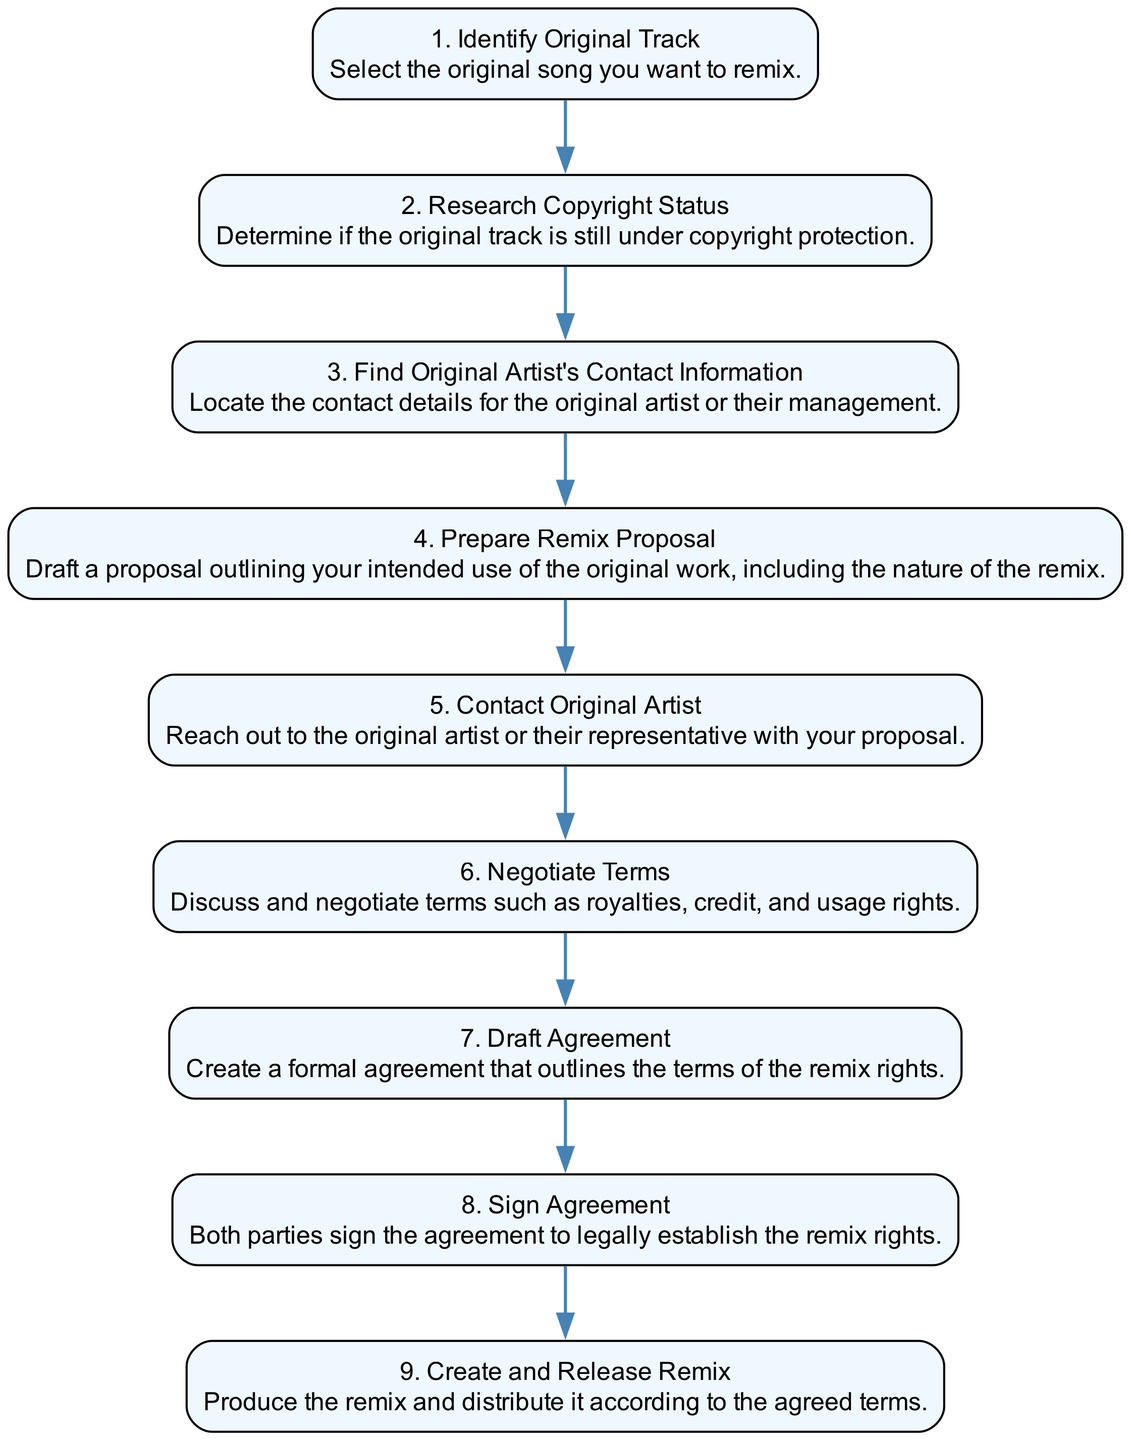What is the first step in the remix rights negotiation process? The first step is to "Identify Original Track", which involves selecting the original song you want to remix.
Answer: Identify Original Track How many steps are involved in the negotiation process? The process includes a total of nine steps as detailed in the diagram.
Answer: 9 What is the step immediately after "Research Copyright Status"? The step immediately after is "Find Original Artist's Contact Information", which involves locating the contact details for the original artist or their management.
Answer: Find Original Artist's Contact Information What must be prepared before contacting the original artist? A "Remix Proposal" must be prepared, outlining the intended use of the original work, including the nature of the remix.
Answer: Remix Proposal What is the final step in the remix rights negotiation sequence? The final step is to "Create and Release Remix", which involves producing the remix and distributing it according to the agreed terms.
Answer: Create and Release Remix Which two steps must occur before drafting an agreement? The two steps that must occur are "Negotiate Terms" and "Contact Original Artist" before drafting the agreement.
Answer: Negotiate Terms and Contact Original Artist What step requires both parties to sign the agreement? The step is "Sign Agreement", where both parties legally establish the remix rights by signing.
Answer: Sign Agreement What does the "Prepare Remix Proposal" step involve? It involves drafting a proposal outlining the intended use of the original work, including the nature of the remix.
Answer: Draft a proposal outlining use What is the primary goal of the "Negotiate Terms" step? The primary goal is to discuss and negotiate terms such as royalties, credit, and usage rights.
Answer: Discuss and negotiate terms 